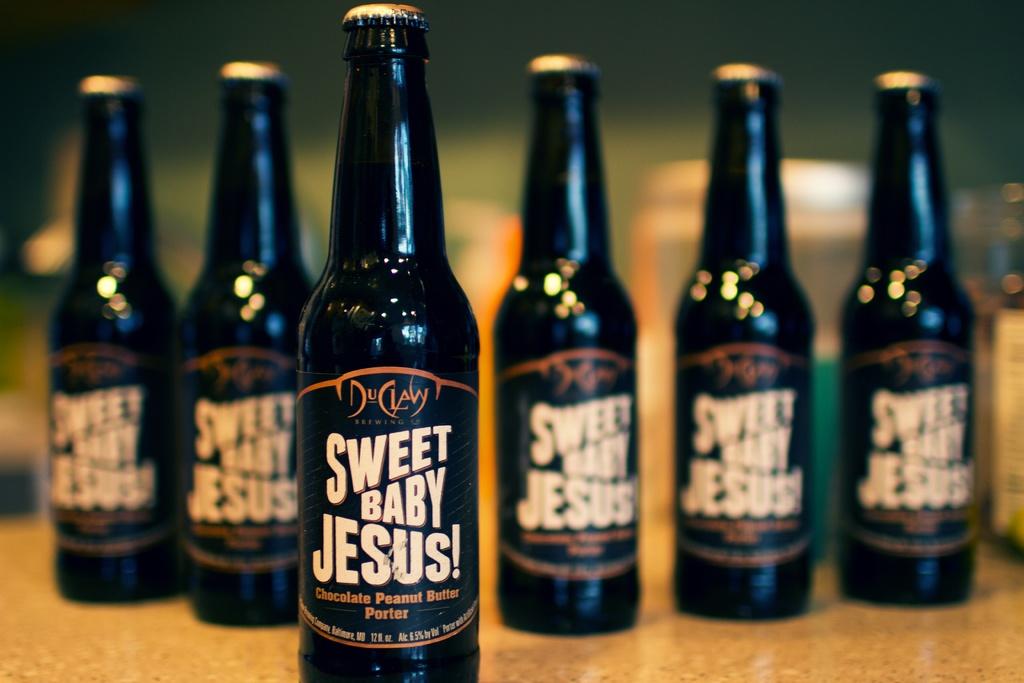What flavor is that beer?
Give a very brief answer. Chocolate peanut butter. What company brewed this beer?
Your answer should be compact. Duclaw. 